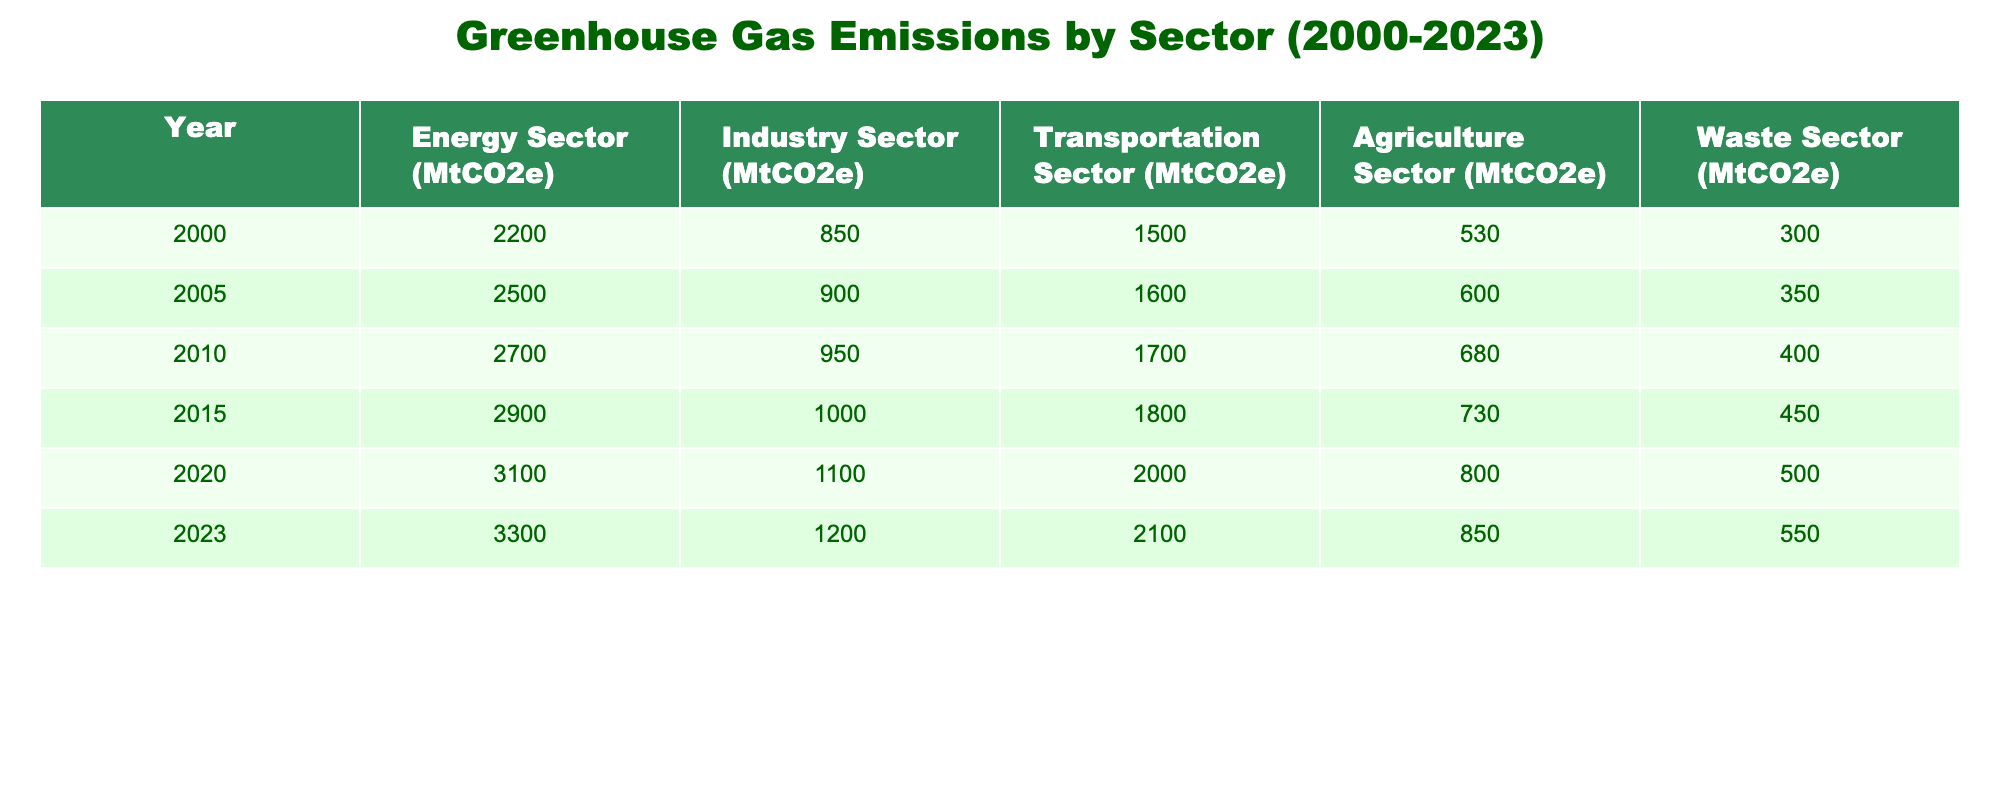What was the total greenhouse gas emissions from the industry sector in 2010? The table shows that the greenhouse gas emissions from the industry sector in 2010 were 950 MtCO2e.
Answer: 950 MtCO2e In which year did the transportation sector emissions first exceed 2000 MtCO2e? According to the table, the transportation sector emissions first exceeded 2000 MtCO2e in the year 2020, reaching 2000 MtCO2e exactly.
Answer: 2020 What is the average greenhouse gas emissions for the agriculture sector from 2000 to 2023? We find the emissions for the agriculture sector for each year (530, 600, 680, 730, 800, 850). The total is (530 + 600 + 680 + 730 + 800 + 850) = 4190 MtCO2e. Dividing this by the number of years (6) gives an average of 4190/6 = 698.33 MtCO2e.
Answer: 698.33 MtCO2e Did the waste sector emissions decrease at any point between 2000 and 2023? Looking at the table, the waste sector emissions consistently increased from 300 MtCO2e in 2000 to 550 MtCO2e in 2023, with no decrease noted.
Answer: No What is the difference in greenhouse gas emissions between the energy sector in 2023 and in 2000? The emissions in the energy sector for 2023 are 3300 MtCO2e and for 2000 are 2200 MtCO2e. The difference is calculated as 3300 - 2200 = 1100 MtCO2e.
Answer: 1100 MtCO2e In 2023, which sector had the highest emissions and what was the value? In 2023, the energy sector had the highest emissions at 3300 MtCO2e compared to all other sectors listed.
Answer: Energy sector, 3300 MtCO2e What was the overall change in emissions across all sectors from 2000 to 2023? To find the overall change, we sum the emissions for all sectors in both years. For 2000: 2200 + 850 + 1500 + 530 + 300 = 4370 MtCO2e; for 2023: 3300 + 1200 + 2100 + 850 + 550 = 8200 MtCO2e. The change is 8200 - 4370 = 3830 MtCO2e.
Answer: 3830 MtCO2e What percentage of the total emissions in 2020 was attributed to the agriculture sector? First, the total emissions for all sectors in 2020 are calculated as 3100 + 1100 + 2000 + 800 + 500 = 7900 MtCO2e. The agriculture sector's emissions in 2020 were 800 MtCO2e. Calculating the percentage: (800/7900) * 100 = 10.13%.
Answer: 10.13% 